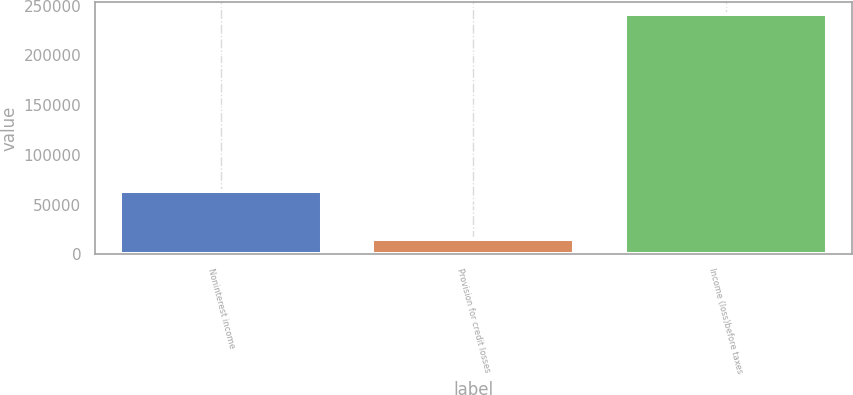<chart> <loc_0><loc_0><loc_500><loc_500><bar_chart><fcel>Noninterest income<fcel>Provision for credit losses<fcel>Income (loss)before taxes<nl><fcel>63288<fcel>15507<fcel>241769<nl></chart> 